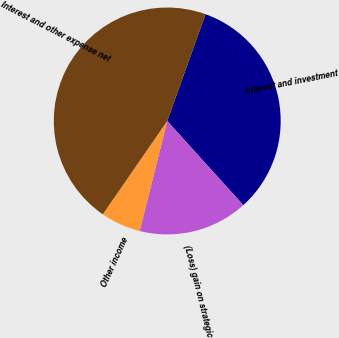Convert chart. <chart><loc_0><loc_0><loc_500><loc_500><pie_chart><fcel>Interest and investment<fcel>(Loss) gain on strategic<fcel>Other income<fcel>Interest and other expense net<nl><fcel>32.83%<fcel>15.6%<fcel>5.71%<fcel>45.86%<nl></chart> 